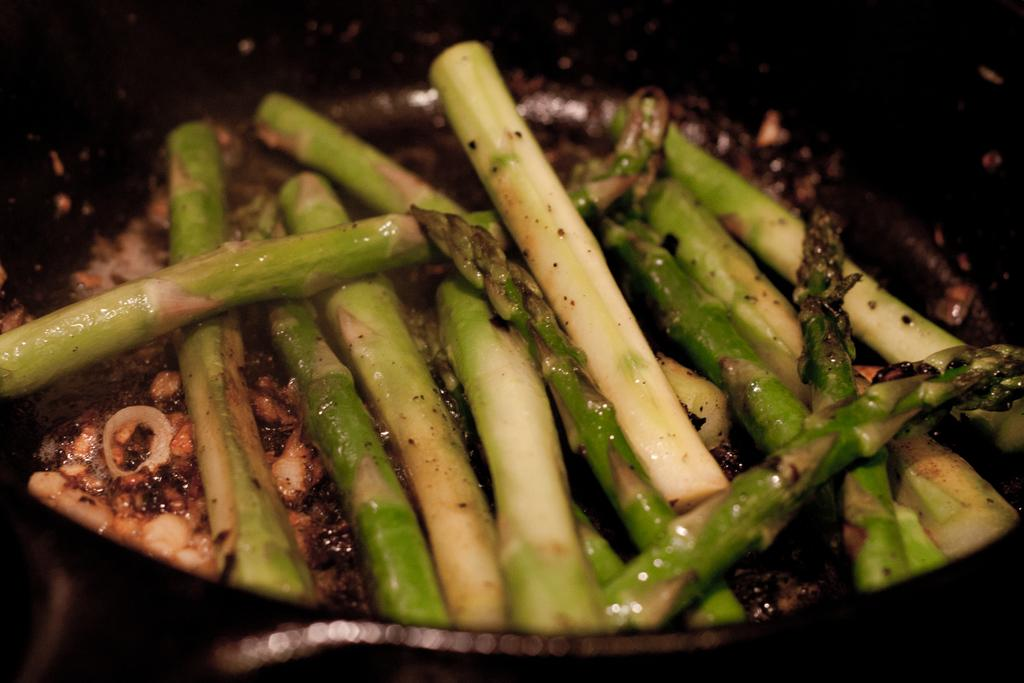What is in the pan that is visible in the image? There is food in a pan in the image. What can be observed about the lighting in the image? The background of the image is dark. How many fingers are visible in the image? There is no reference to fingers or hands in the image, so it is not possible to determine how many fingers might be visible. 